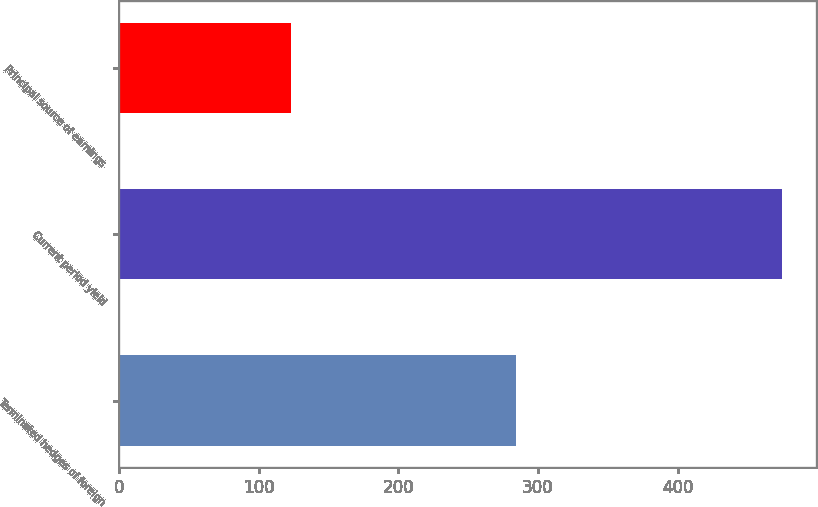<chart> <loc_0><loc_0><loc_500><loc_500><bar_chart><fcel>Terminated hedges of foreign<fcel>Current period yield<fcel>Principal source of earnings<nl><fcel>284<fcel>475<fcel>123<nl></chart> 